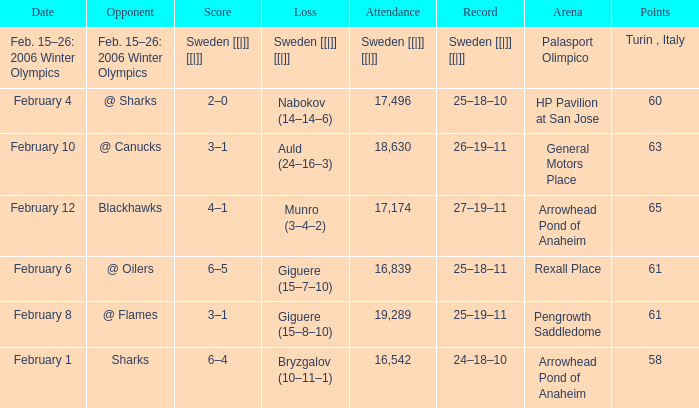What is the record at Arrowhead Pond of Anaheim, when the loss was Bryzgalov (10–11–1)? 24–18–10. 